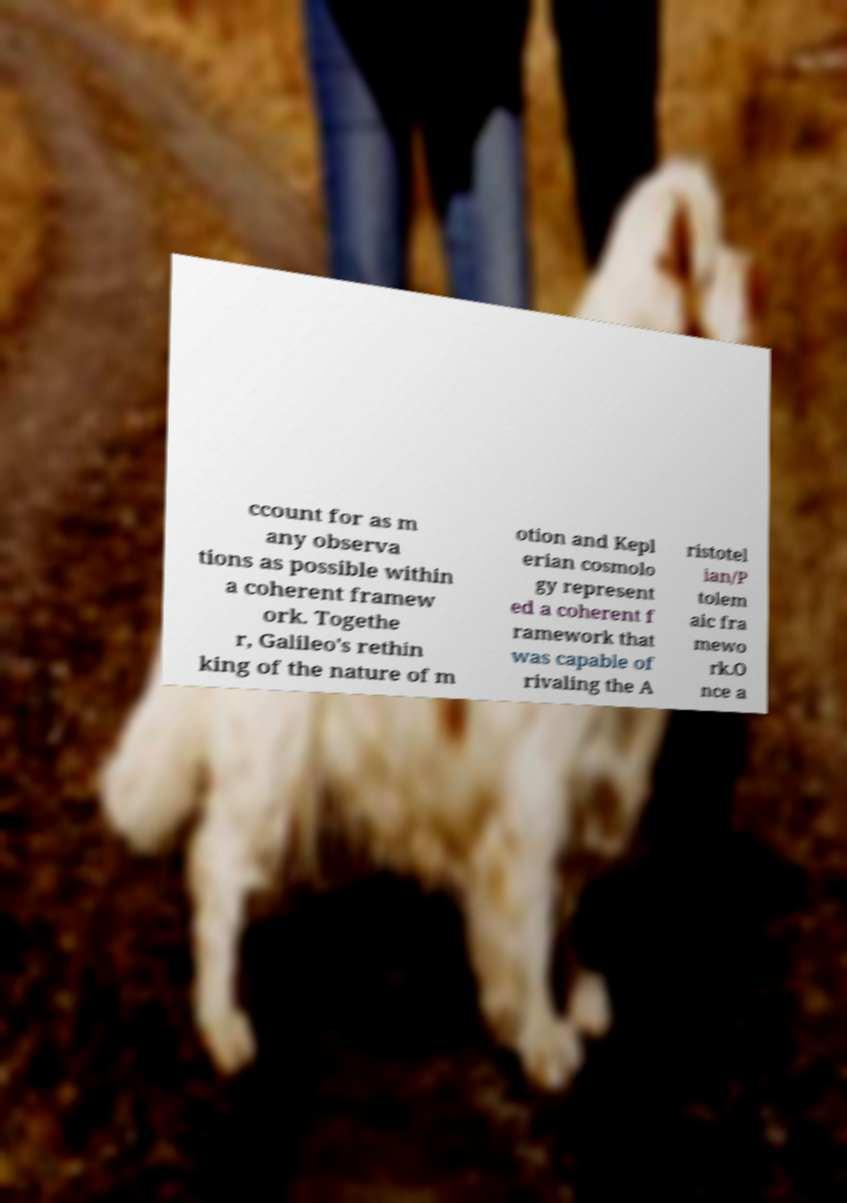Can you accurately transcribe the text from the provided image for me? ccount for as m any observa tions as possible within a coherent framew ork. Togethe r, Galileo's rethin king of the nature of m otion and Kepl erian cosmolo gy represent ed a coherent f ramework that was capable of rivaling the A ristotel ian/P tolem aic fra mewo rk.O nce a 